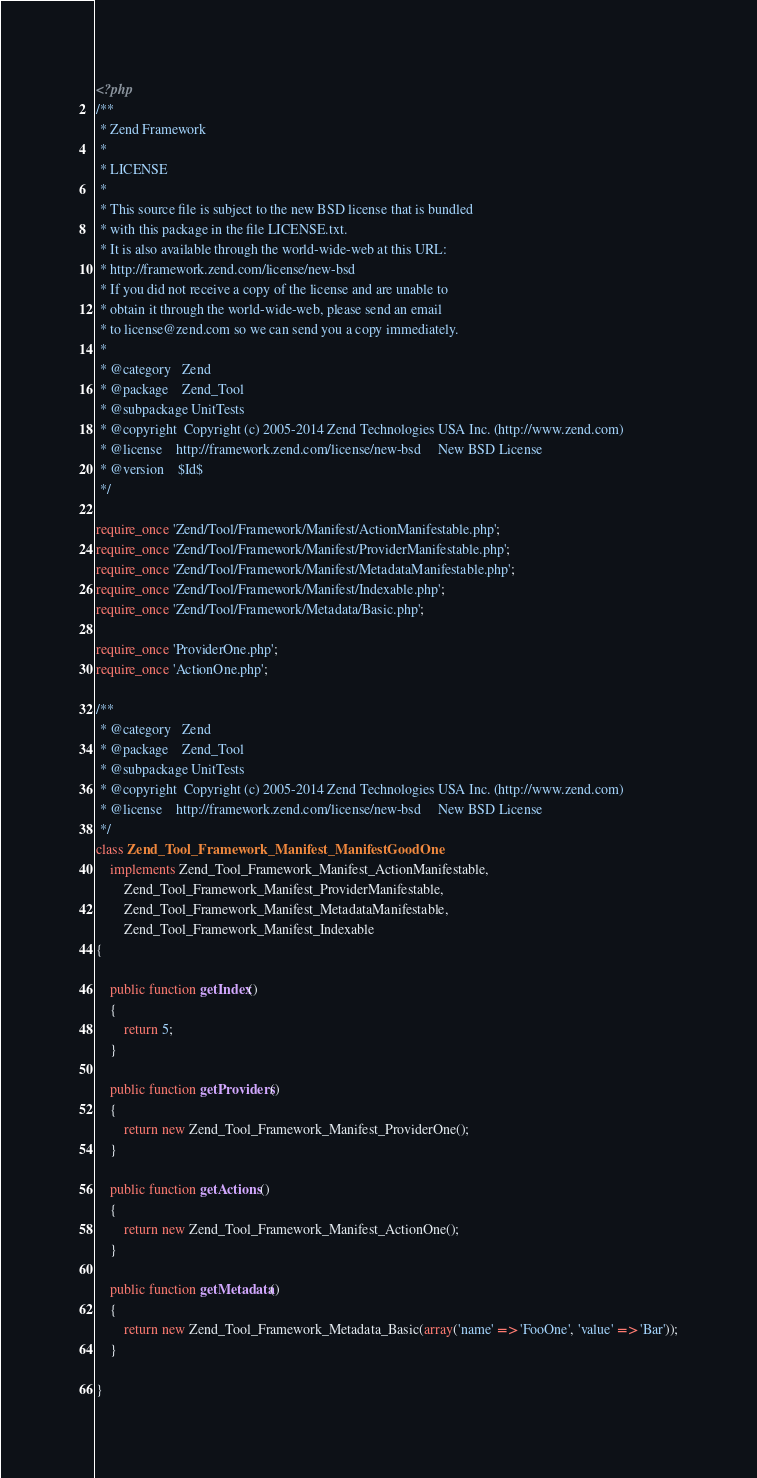<code> <loc_0><loc_0><loc_500><loc_500><_PHP_><?php
/**
 * Zend Framework
 *
 * LICENSE
 *
 * This source file is subject to the new BSD license that is bundled
 * with this package in the file LICENSE.txt.
 * It is also available through the world-wide-web at this URL:
 * http://framework.zend.com/license/new-bsd
 * If you did not receive a copy of the license and are unable to
 * obtain it through the world-wide-web, please send an email
 * to license@zend.com so we can send you a copy immediately.
 *
 * @category   Zend
 * @package    Zend_Tool
 * @subpackage UnitTests
 * @copyright  Copyright (c) 2005-2014 Zend Technologies USA Inc. (http://www.zend.com)
 * @license    http://framework.zend.com/license/new-bsd     New BSD License
 * @version    $Id$
 */

require_once 'Zend/Tool/Framework/Manifest/ActionManifestable.php';
require_once 'Zend/Tool/Framework/Manifest/ProviderManifestable.php';
require_once 'Zend/Tool/Framework/Manifest/MetadataManifestable.php';
require_once 'Zend/Tool/Framework/Manifest/Indexable.php';
require_once 'Zend/Tool/Framework/Metadata/Basic.php';

require_once 'ProviderOne.php';
require_once 'ActionOne.php';

/**
 * @category   Zend
 * @package    Zend_Tool
 * @subpackage UnitTests
 * @copyright  Copyright (c) 2005-2014 Zend Technologies USA Inc. (http://www.zend.com)
 * @license    http://framework.zend.com/license/new-bsd     New BSD License
 */
class Zend_Tool_Framework_Manifest_ManifestGoodOne
    implements Zend_Tool_Framework_Manifest_ActionManifestable,
        Zend_Tool_Framework_Manifest_ProviderManifestable,
        Zend_Tool_Framework_Manifest_MetadataManifestable,
        Zend_Tool_Framework_Manifest_Indexable
{

    public function getIndex()
    {
        return 5;
    }

    public function getProviders()
    {
        return new Zend_Tool_Framework_Manifest_ProviderOne();
    }

    public function getActions()
    {
        return new Zend_Tool_Framework_Manifest_ActionOne();
    }

    public function getMetadata()
    {
        return new Zend_Tool_Framework_Metadata_Basic(array('name' => 'FooOne', 'value' => 'Bar'));
    }

}
</code> 